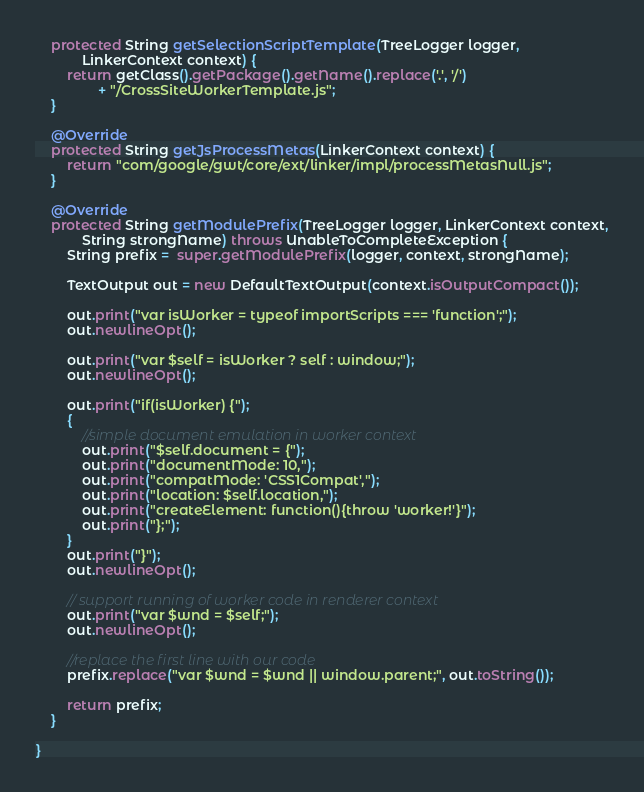Convert code to text. <code><loc_0><loc_0><loc_500><loc_500><_Java_>	protected String getSelectionScriptTemplate(TreeLogger logger,
			LinkerContext context) {
		return getClass().getPackage().getName().replace('.', '/')
				+ "/CrossSiteWorkerTemplate.js";
	}
	
	@Override
	protected String getJsProcessMetas(LinkerContext context) {
		return "com/google/gwt/core/ext/linker/impl/processMetasNull.js";
	}
	
	@Override
	protected String getModulePrefix(TreeLogger logger, LinkerContext context,
			String strongName) throws UnableToCompleteException {
		String prefix =  super.getModulePrefix(logger, context, strongName);
		
		TextOutput out = new DefaultTextOutput(context.isOutputCompact());
		
		out.print("var isWorker = typeof importScripts === 'function';");
		out.newlineOpt();
		
		out.print("var $self = isWorker ? self : window;");
		out.newlineOpt();
		
		out.print("if(isWorker) {");
		{
			//simple document emulation in worker context
			out.print("$self.document = {");
			out.print("documentMode: 10,");
			out.print("compatMode: 'CSS1Compat',");
			out.print("location: $self.location,");
			out.print("createElement: function(){throw 'worker!'}");
			out.print("};");
		}
		out.print("}");
		out.newlineOpt();

		// support running of worker code in renderer context
		out.print("var $wnd = $self;");
		out.newlineOpt();
		
		//replace the first line with our code
		prefix.replace("var $wnd = $wnd || window.parent;", out.toString());
		
		return prefix;
	}

}
</code> 